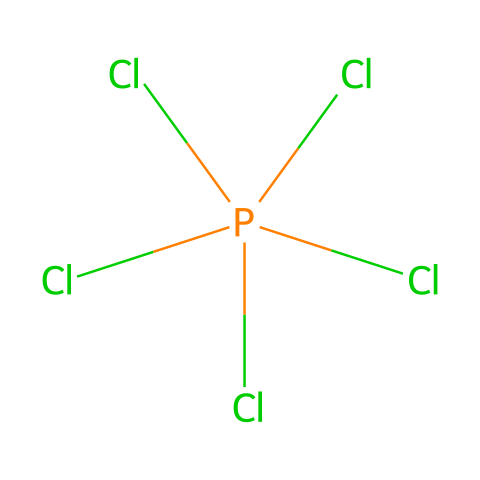What is the molecular formula of the compound represented by the SMILES? The SMILES representation shows 1 phosphorus (P) atom and 5 chlorine (Cl) atoms, which combines to form the molecular formula PCl5.
Answer: PCl5 How many chlorine atoms are bonded to the phosphorus atom? The chemical structure indicates there are five chlorine (Cl) atoms directly bonded to one phosphorus (P) atom.
Answer: five What type of hybridization does phosphorus exhibit in phosphorus pentachloride? In PCl5, phosphorus is surrounded by five chlorine atoms, which leads to sp3d hybridization to accommodate the expanded octet.
Answer: sp3d Why is phosphorus pentachloride considered a hypervalent compound? Phosphorus pentachloride has more than eight electrons in its valence shell due to the presence of five bonding pairs with chlorine, thus exceeding the octet rule.
Answer: hypervalent What is the shape of the phosphorus pentachloride molecule? The arrangement of five chlorine atoms around a central phosphorus atom leads to a trigonal bipyramidal geometry.
Answer: trigonal bipyramidal Is phosphorus pentachloride a solid, liquid, or gas at room temperature? Phosphorus pentachloride is typically a solid at room temperature, characterized by its white crystalline appearance.
Answer: solid What role does phosphorus pentachloride play in fire extinguishers? It acts as a chemical fire suppressant, particularly in fires involving organic materials and metals due to its ability to react exothermically.
Answer: suppressant 